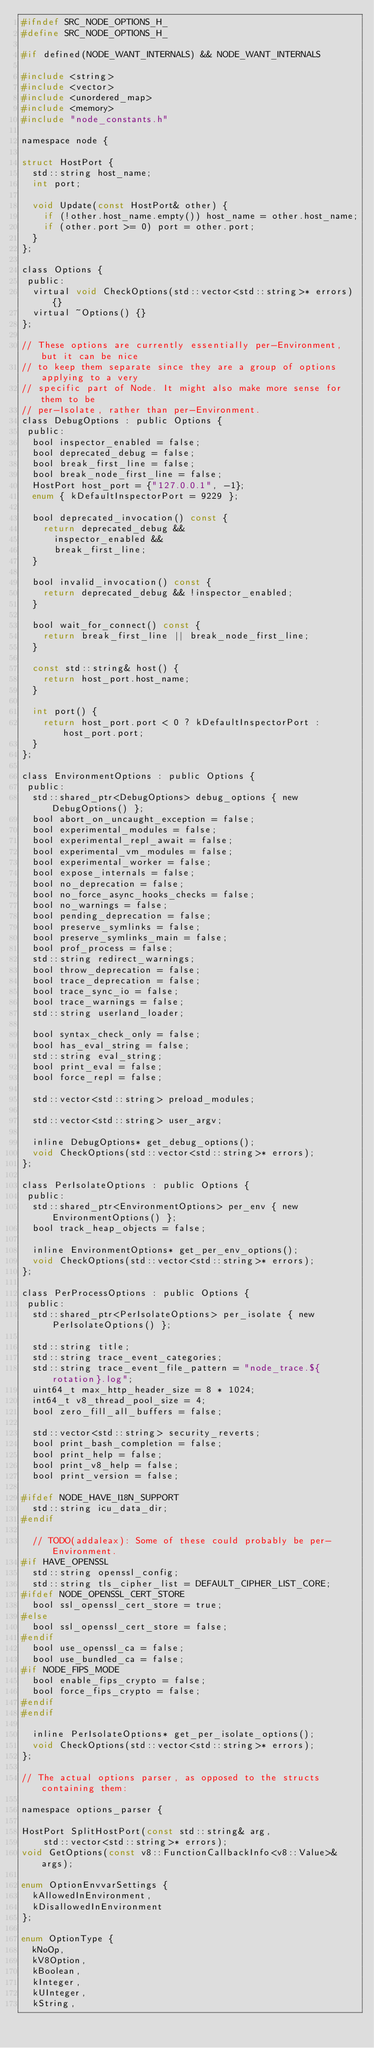Convert code to text. <code><loc_0><loc_0><loc_500><loc_500><_C_>#ifndef SRC_NODE_OPTIONS_H_
#define SRC_NODE_OPTIONS_H_

#if defined(NODE_WANT_INTERNALS) && NODE_WANT_INTERNALS

#include <string>
#include <vector>
#include <unordered_map>
#include <memory>
#include "node_constants.h"

namespace node {

struct HostPort {
  std::string host_name;
  int port;

  void Update(const HostPort& other) {
    if (!other.host_name.empty()) host_name = other.host_name;
    if (other.port >= 0) port = other.port;
  }
};

class Options {
 public:
  virtual void CheckOptions(std::vector<std::string>* errors) {}
  virtual ~Options() {}
};

// These options are currently essentially per-Environment, but it can be nice
// to keep them separate since they are a group of options applying to a very
// specific part of Node. It might also make more sense for them to be
// per-Isolate, rather than per-Environment.
class DebugOptions : public Options {
 public:
  bool inspector_enabled = false;
  bool deprecated_debug = false;
  bool break_first_line = false;
  bool break_node_first_line = false;
  HostPort host_port = {"127.0.0.1", -1};
  enum { kDefaultInspectorPort = 9229 };

  bool deprecated_invocation() const {
    return deprecated_debug &&
      inspector_enabled &&
      break_first_line;
  }

  bool invalid_invocation() const {
    return deprecated_debug && !inspector_enabled;
  }

  bool wait_for_connect() const {
    return break_first_line || break_node_first_line;
  }

  const std::string& host() {
    return host_port.host_name;
  }

  int port() {
    return host_port.port < 0 ? kDefaultInspectorPort : host_port.port;
  }
};

class EnvironmentOptions : public Options {
 public:
  std::shared_ptr<DebugOptions> debug_options { new DebugOptions() };
  bool abort_on_uncaught_exception = false;
  bool experimental_modules = false;
  bool experimental_repl_await = false;
  bool experimental_vm_modules = false;
  bool experimental_worker = false;
  bool expose_internals = false;
  bool no_deprecation = false;
  bool no_force_async_hooks_checks = false;
  bool no_warnings = false;
  bool pending_deprecation = false;
  bool preserve_symlinks = false;
  bool preserve_symlinks_main = false;
  bool prof_process = false;
  std::string redirect_warnings;
  bool throw_deprecation = false;
  bool trace_deprecation = false;
  bool trace_sync_io = false;
  bool trace_warnings = false;
  std::string userland_loader;

  bool syntax_check_only = false;
  bool has_eval_string = false;
  std::string eval_string;
  bool print_eval = false;
  bool force_repl = false;

  std::vector<std::string> preload_modules;

  std::vector<std::string> user_argv;

  inline DebugOptions* get_debug_options();
  void CheckOptions(std::vector<std::string>* errors);
};

class PerIsolateOptions : public Options {
 public:
  std::shared_ptr<EnvironmentOptions> per_env { new EnvironmentOptions() };
  bool track_heap_objects = false;

  inline EnvironmentOptions* get_per_env_options();
  void CheckOptions(std::vector<std::string>* errors);
};

class PerProcessOptions : public Options {
 public:
  std::shared_ptr<PerIsolateOptions> per_isolate { new PerIsolateOptions() };

  std::string title;
  std::string trace_event_categories;
  std::string trace_event_file_pattern = "node_trace.${rotation}.log";
  uint64_t max_http_header_size = 8 * 1024;
  int64_t v8_thread_pool_size = 4;
  bool zero_fill_all_buffers = false;

  std::vector<std::string> security_reverts;
  bool print_bash_completion = false;
  bool print_help = false;
  bool print_v8_help = false;
  bool print_version = false;

#ifdef NODE_HAVE_I18N_SUPPORT
  std::string icu_data_dir;
#endif

  // TODO(addaleax): Some of these could probably be per-Environment.
#if HAVE_OPENSSL
  std::string openssl_config;
  std::string tls_cipher_list = DEFAULT_CIPHER_LIST_CORE;
#ifdef NODE_OPENSSL_CERT_STORE
  bool ssl_openssl_cert_store = true;
#else
  bool ssl_openssl_cert_store = false;
#endif
  bool use_openssl_ca = false;
  bool use_bundled_ca = false;
#if NODE_FIPS_MODE
  bool enable_fips_crypto = false;
  bool force_fips_crypto = false;
#endif
#endif

  inline PerIsolateOptions* get_per_isolate_options();
  void CheckOptions(std::vector<std::string>* errors);
};

// The actual options parser, as opposed to the structs containing them:

namespace options_parser {

HostPort SplitHostPort(const std::string& arg,
    std::vector<std::string>* errors);
void GetOptions(const v8::FunctionCallbackInfo<v8::Value>& args);

enum OptionEnvvarSettings {
  kAllowedInEnvironment,
  kDisallowedInEnvironment
};

enum OptionType {
  kNoOp,
  kV8Option,
  kBoolean,
  kInteger,
  kUInteger,
  kString,</code> 